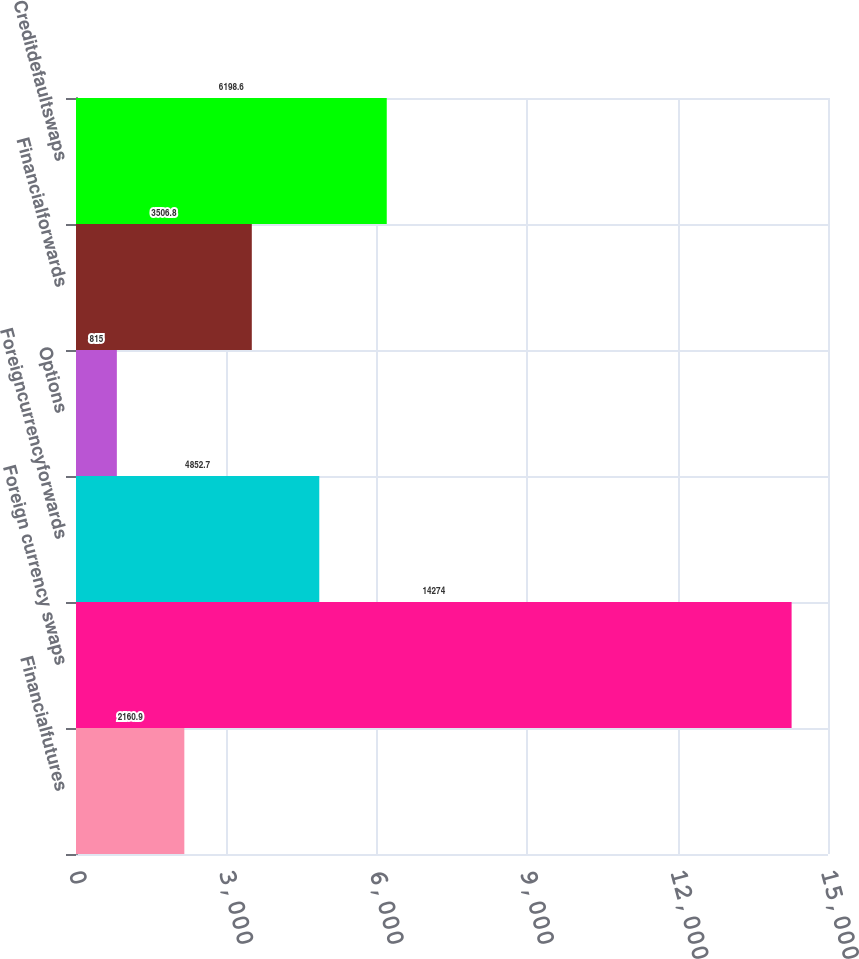Convert chart to OTSL. <chart><loc_0><loc_0><loc_500><loc_500><bar_chart><fcel>Financialfutures<fcel>Foreign currency swaps<fcel>Foreigncurrencyforwards<fcel>Options<fcel>Financialforwards<fcel>Creditdefaultswaps<nl><fcel>2160.9<fcel>14274<fcel>4852.7<fcel>815<fcel>3506.8<fcel>6198.6<nl></chart> 